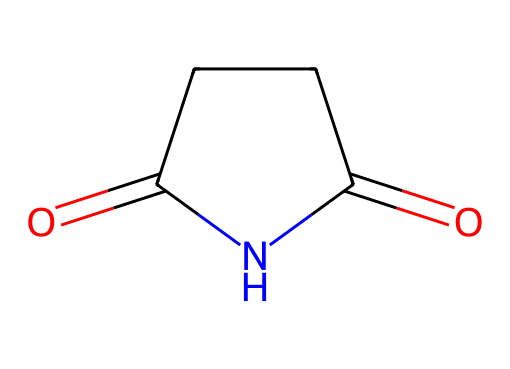What is the molecular formula of succinimide? By analyzing the SMILES representation O=C1CCC(=O)N1, we can identify the constituent atoms. Counting the carbon (C), oxygen (O), and nitrogen (N) atoms gives us 4 carbons, 2 oxygens, and 1 nitrogen. Therefore, the molecular formula is C4H5NO2.
Answer: C4H5NO2 How many rings are present in succinimide? The representation O=C1CCC(=O)N1 indicates that there is a cyclic structure since the number '1' designates the start and end of a ring. There is one cyclic component in this structure, hence the total is one ring.
Answer: 1 What type of functional groups are present in succinimide? Examining the SMILES O=C1CCC(=O)N1, we see a carbonyl group (C=O) and an amide group (–C(=O)N–) in the structure. These are characteristic of imides, which consist of a cyclic arrangement and keto groups.
Answer: carbonyl and amide What type of compound is succinimide classified as? Based on the structure shown in the SMILES representation, where there are two carbonyl groups and a nitrogen in the ring, succinimide belongs to the class of imides. This classification is reinforced due to its specific bonding pattern and ring structure.
Answer: imide How many total atoms are present in succinimide? The analysis of the molecule through its SMILES O=C1CCC(=O)N1 reveals that it has a total of 4 carbon atoms, 5 hydrogen atoms, 2 oxygen atoms, and 1 nitrogen atom. Adding these together gives 4 + 5 + 2 + 1, resulting in a total of 12 atoms.
Answer: 12 What is the bond type between the nitrogen and the neighboring carbon in succinimide? In the SMILES O=C1CCC(=O)N1, the nitrogen atom is bonded to a carbon atom with a single bond, indicated by the absence of any symbols explicitly showing it as a double bond. This means the bond type is a single bond.
Answer: single 